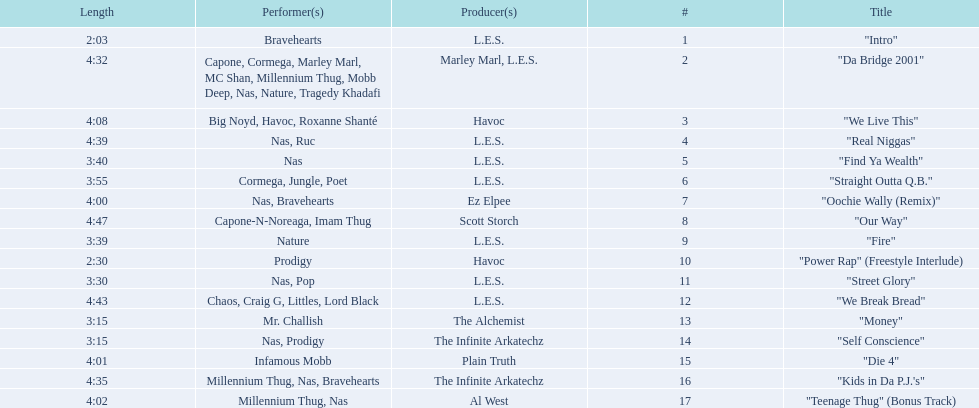What are the track lengths on the album? 2:03, 4:32, 4:08, 4:39, 3:40, 3:55, 4:00, 4:47, 3:39, 2:30, 3:30, 4:43, 3:15, 3:15, 4:01, 4:35, 4:02. What is the longest length? 4:47. 